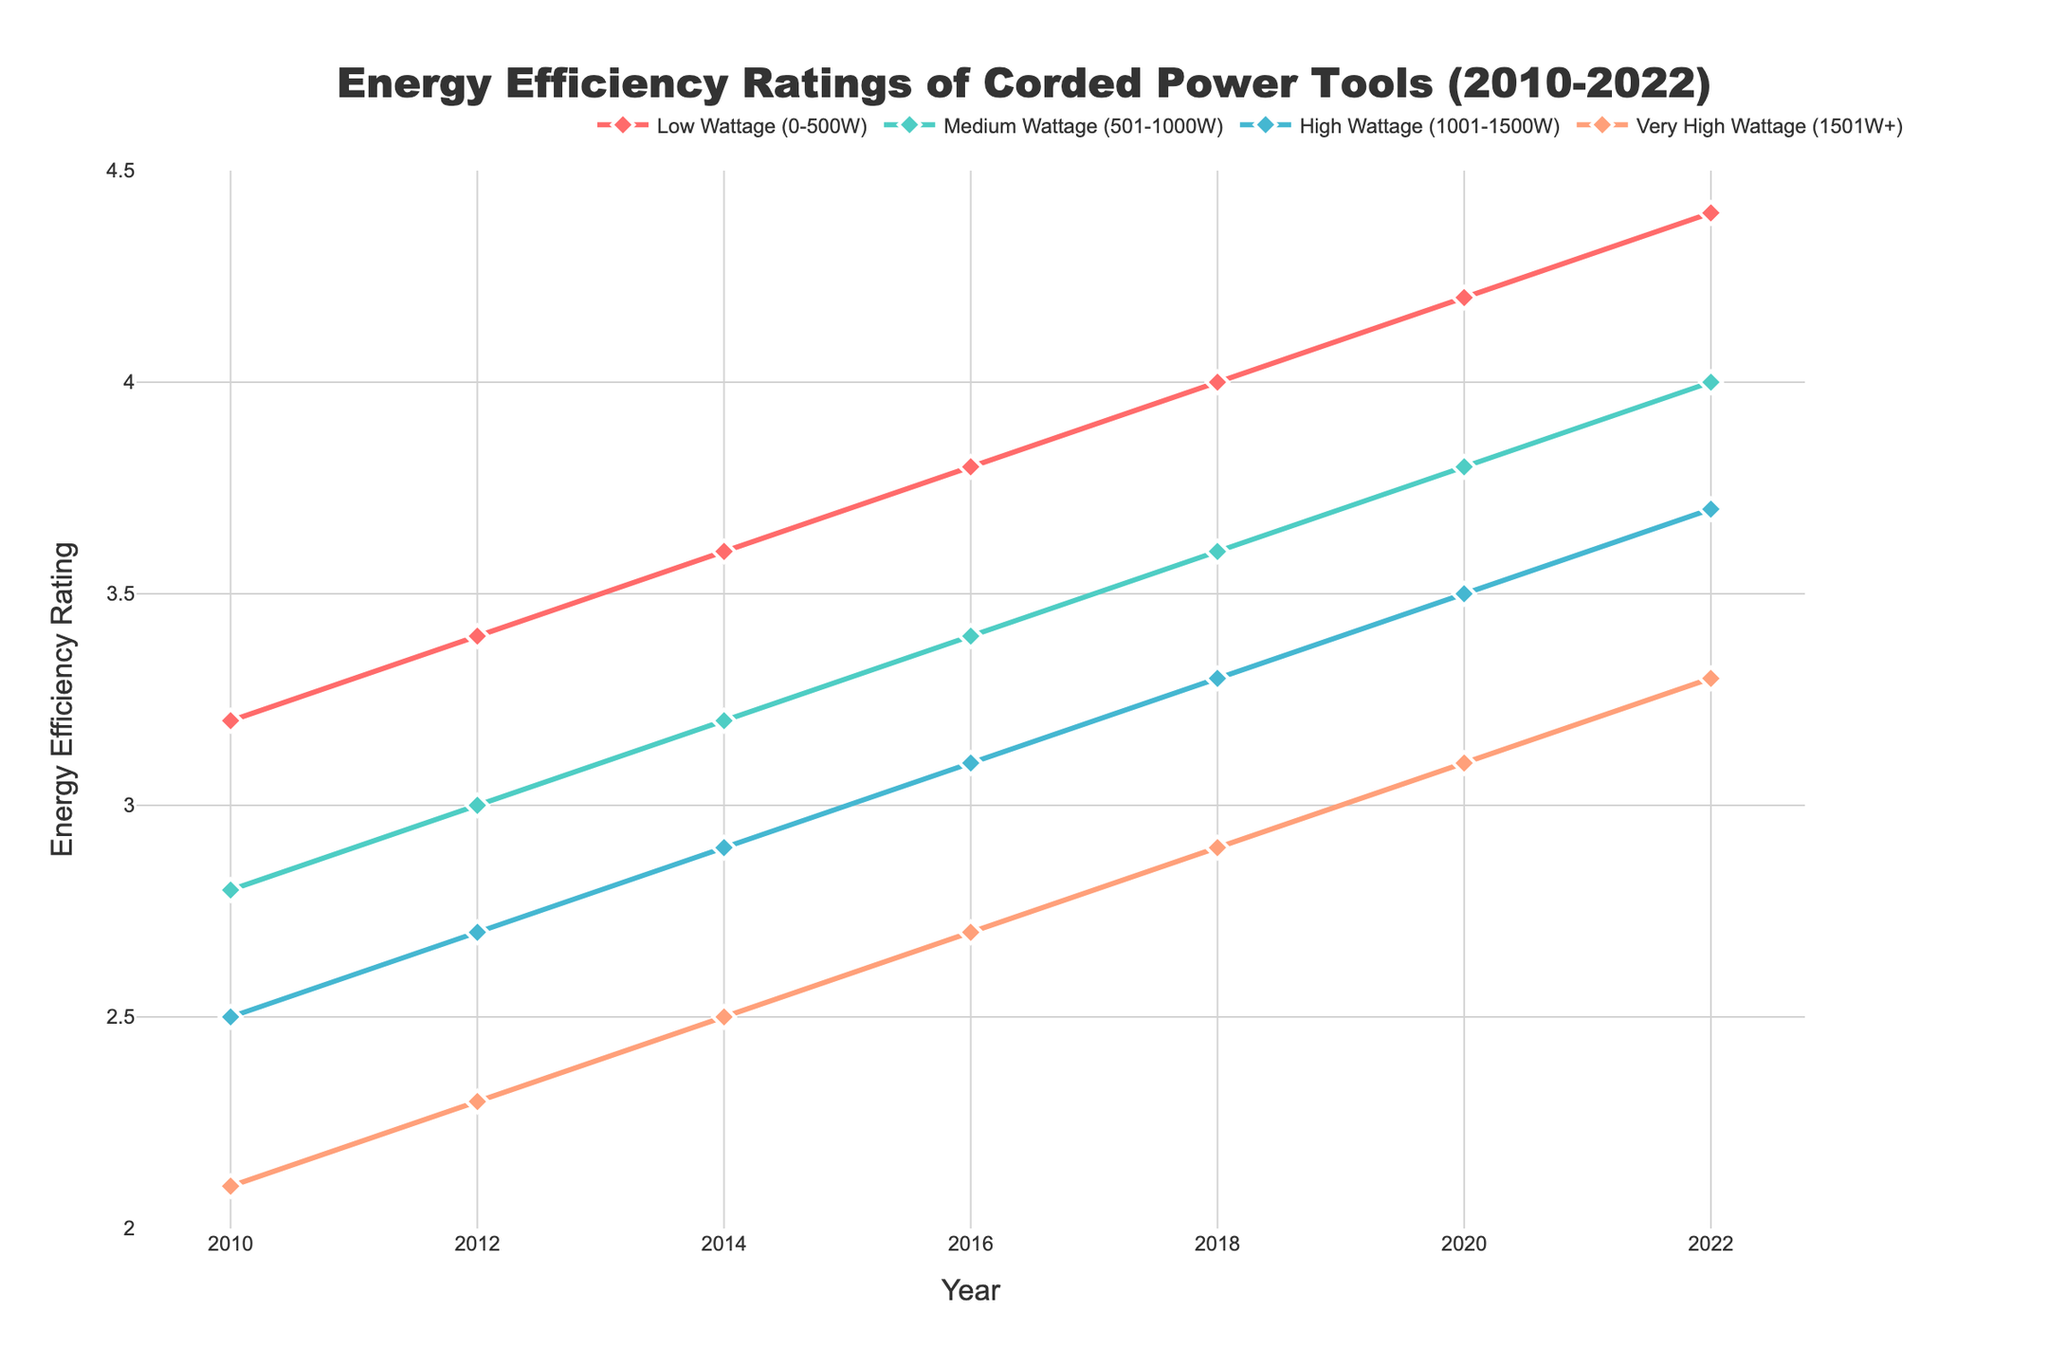what is the energy efficiency rating for low wattage tools in 2010? Refer to the line corresponding to 'Low Wattage (0-500W)' and find the value at 2010.
Answer: 3.2 how has the energy efficiency rating of medium wattage tools changed from 2010 to 2022? Check the starting and ending points of the 'Medium Wattage (501-1000W)' line. Subtract the 2010 rating from the 2022 rating (4.0 - 2.8).
Answer: Increased by 1.2 which wattage category shows the highest energy efficiency rating in 2018? Look at the ratings for all categories in 2018 and identify the highest one. The 'Low Wattage (0-500W)' category has the highest rating.
Answer: Low Wattage (0-500W) between which years did the very high wattage category (1501W+) experience the most significant increase in energy efficiency? Compare the increases by checking the steepness of the line for 'Very High Wattage (1501W+)' between successive years. The steepest slope appears between 2018 and 2020.
Answer: 2018 to 2020 which category has the most consistent (steady) increase in energy efficiency ratings over time? Assess the smoothness of the lines. 'Low Wattage (0-500W)' exhibits the most consistent upward trend without large fluctuations.
Answer: Low Wattage (0-500W) what is the difference between the energy efficiency rating of high wattage tools in 2014 and very high wattage tools in 2022? Subtract the 2014 rating of 'High Wattage (1001-1500W)' from the 2022 rating of 'Very High Wattage (1501W+)' (3.3 - 2.9).
Answer: 0.4 how much did the energy efficiency rating of low wattage tools increase from 2010 to 2014? Subtract the value in 2010 from the value in 2014 for 'Low Wattage (0-500W)' (3.6 - 3.2).
Answer: 0.4 which wattage category had the second highest energy efficiency rating in 2020? Find the second highest value in the column for 2020. 'Medium Wattage (501-1000W)' had the second highest rating.
Answer: Medium Wattage (501-1000W) what is the average energy efficiency rating of very high wattage tools between 2014 and 2022? Add the ratings for 2014, 2016, 2018, 2020, and 2022, then divide by the number of years: (2.5 + 2.7 + 2.9 + 3.1 + 3.3)/5.
Answer: 2.9 what is the trend in energy efficiency ratings for high wattage tools? Describe the general pattern over the years. The energy efficiency of 'High Wattage (1001-1500W)' steadily increases from 2010 to 2022.
Answer: Steady increase 